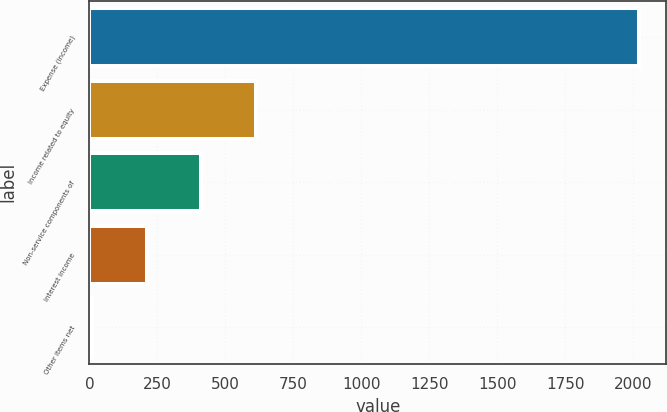Convert chart to OTSL. <chart><loc_0><loc_0><loc_500><loc_500><bar_chart><fcel>Expense (income)<fcel>Income related to equity<fcel>Non-service components of<fcel>Interest income<fcel>Other items net<nl><fcel>2019<fcel>612.7<fcel>411.8<fcel>210.9<fcel>10<nl></chart> 